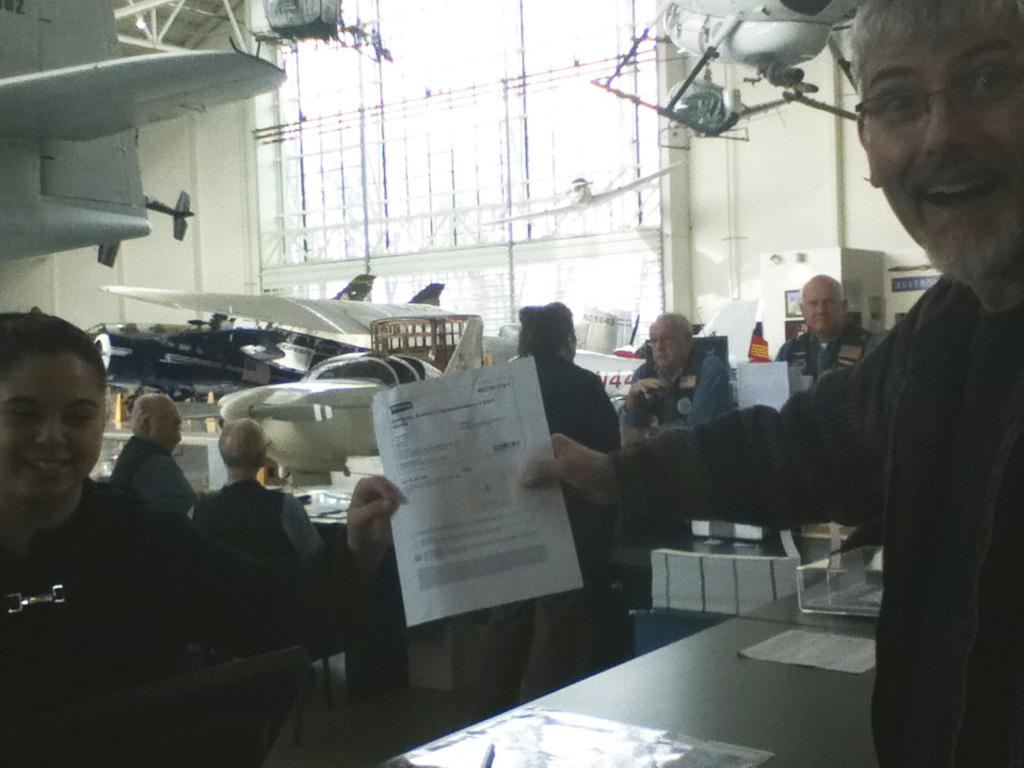How many people are in the image? There are two persons in the image. What are the persons holding in the image? The persons are holding a paper. What is the facial expression of the persons in the image? The persons are smiling. What type of furniture is present in the image? There is a table and chairs in the image. What is the primary object on the table? There are pages on the table. What type of transportation is depicted in the image? There are planes in the image. What is the main structure in the background of the image? There is a board in the image. What type of architectural feature is present in the image? There is a wall in the image. What other objects can be seen in the image? There are other objects in the image. How many flowers are on the table in the image? There are no flowers present on the table in the image. 